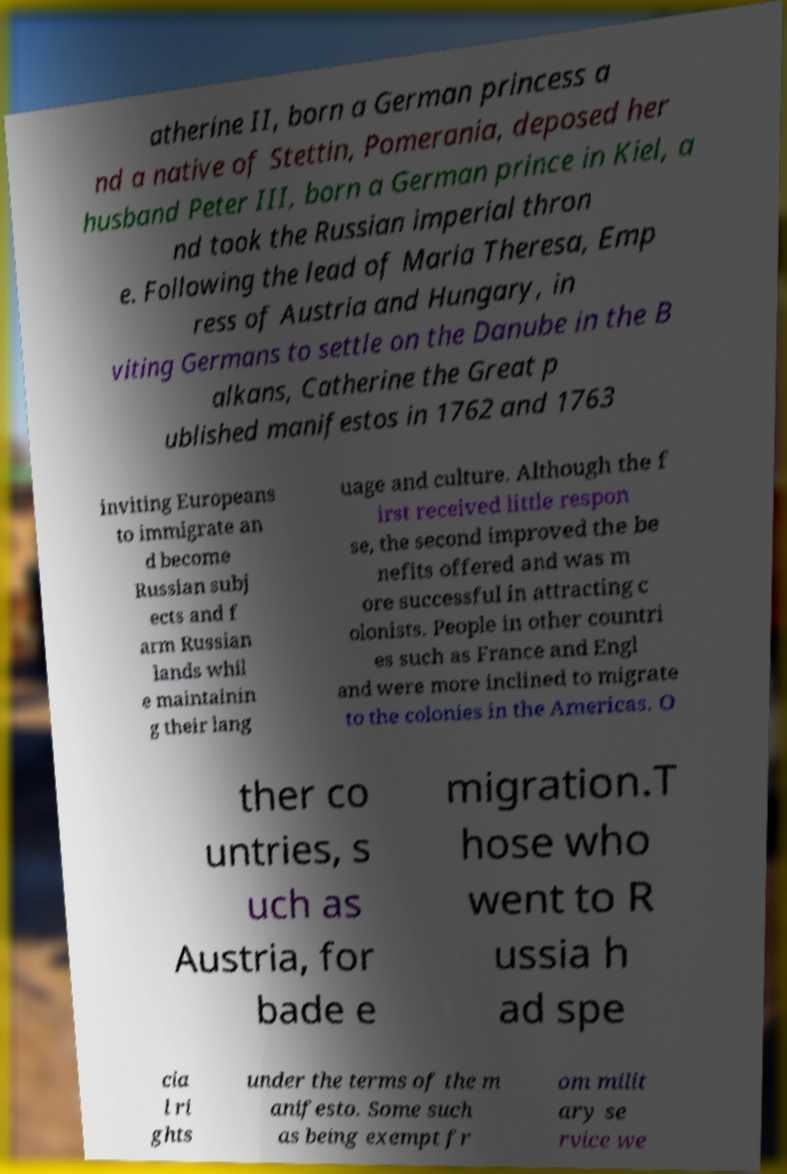There's text embedded in this image that I need extracted. Can you transcribe it verbatim? atherine II, born a German princess a nd a native of Stettin, Pomerania, deposed her husband Peter III, born a German prince in Kiel, a nd took the Russian imperial thron e. Following the lead of Maria Theresa, Emp ress of Austria and Hungary, in viting Germans to settle on the Danube in the B alkans, Catherine the Great p ublished manifestos in 1762 and 1763 inviting Europeans to immigrate an d become Russian subj ects and f arm Russian lands whil e maintainin g their lang uage and culture. Although the f irst received little respon se, the second improved the be nefits offered and was m ore successful in attracting c olonists. People in other countri es such as France and Engl and were more inclined to migrate to the colonies in the Americas. O ther co untries, s uch as Austria, for bade e migration.T hose who went to R ussia h ad spe cia l ri ghts under the terms of the m anifesto. Some such as being exempt fr om milit ary se rvice we 